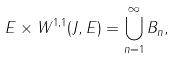Convert formula to latex. <formula><loc_0><loc_0><loc_500><loc_500>E \times W ^ { 1 , 1 } ( J , E ) = \bigcup _ { n = 1 } ^ { \infty } B _ { n } ,</formula> 